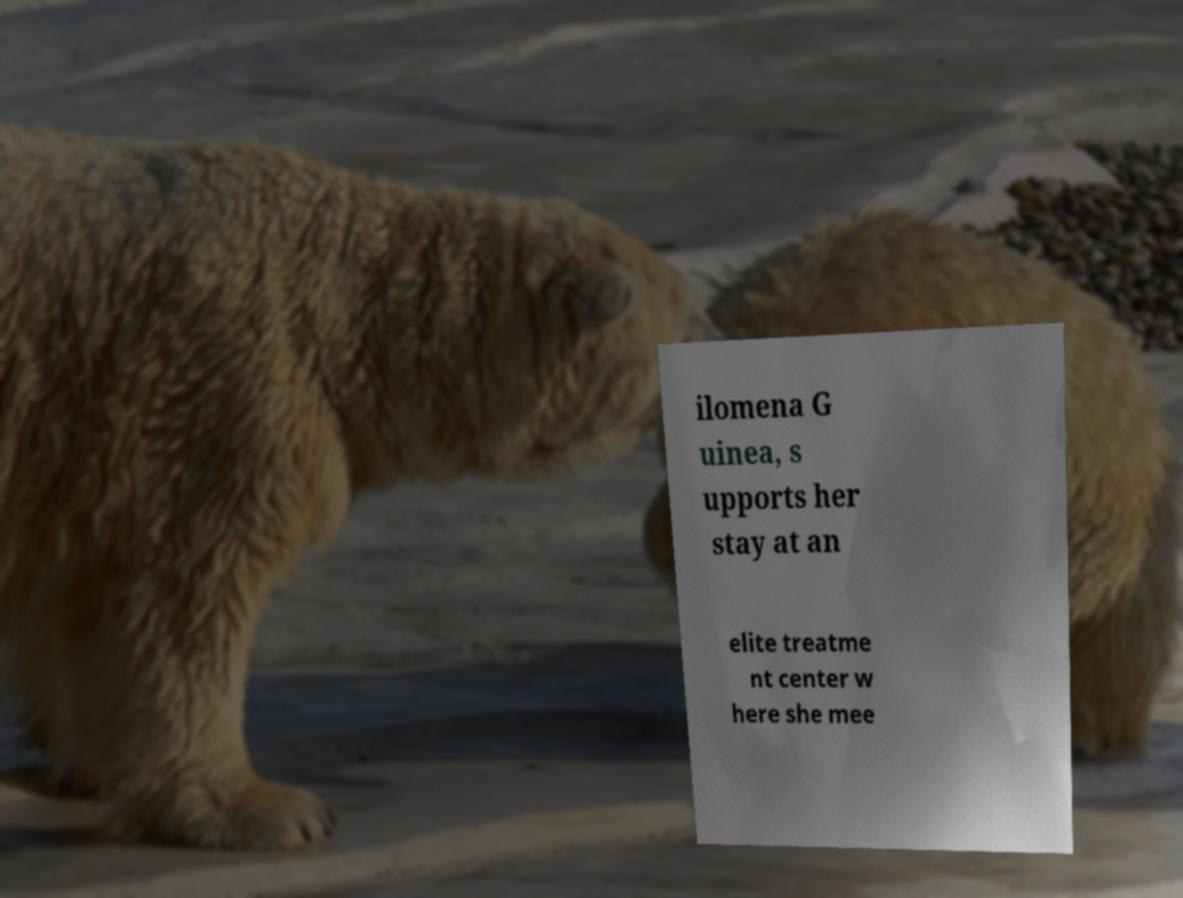For documentation purposes, I need the text within this image transcribed. Could you provide that? ilomena G uinea, s upports her stay at an elite treatme nt center w here she mee 